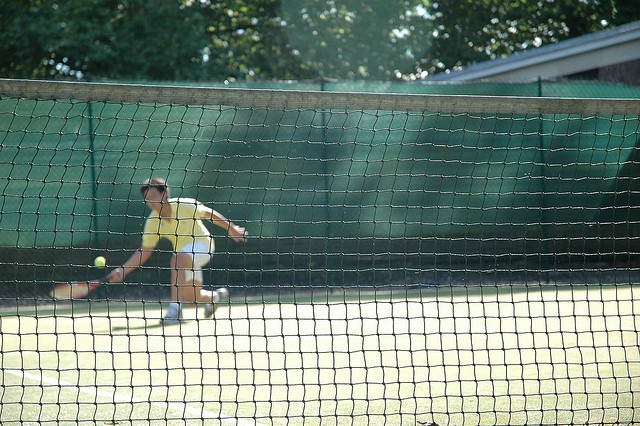Describe the objects in this image and their specific colors. I can see people in black, gray, tan, and darkgray tones, tennis racket in black, darkgray, gray, and tan tones, and sports ball in black, lightgreen, darkgreen, khaki, and olive tones in this image. 